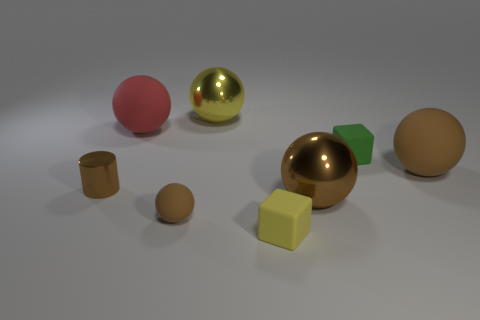Does the cylinder have the same color as the small matte sphere?
Your answer should be compact. Yes. What size is the brown metal object left of the large rubber ball to the left of the tiny green block?
Offer a very short reply. Small. Is there anything else that has the same shape as the small shiny object?
Your response must be concise. No. Are there fewer purple cylinders than small matte balls?
Make the answer very short. Yes. There is a brown object that is in front of the small brown cylinder and to the right of the yellow metallic sphere; what is its material?
Offer a very short reply. Metal. There is a small thing behind the tiny brown metal cylinder; is there a large brown shiny thing behind it?
Give a very brief answer. No. How many objects are large gray blocks or big things?
Your answer should be very brief. 4. What shape is the small rubber thing that is on the left side of the tiny green object and behind the yellow rubber cube?
Your answer should be compact. Sphere. Are the big red ball in front of the yellow metallic ball and the small brown ball made of the same material?
Give a very brief answer. Yes. What number of objects are big yellow balls or brown things right of the red rubber object?
Your response must be concise. 4. 